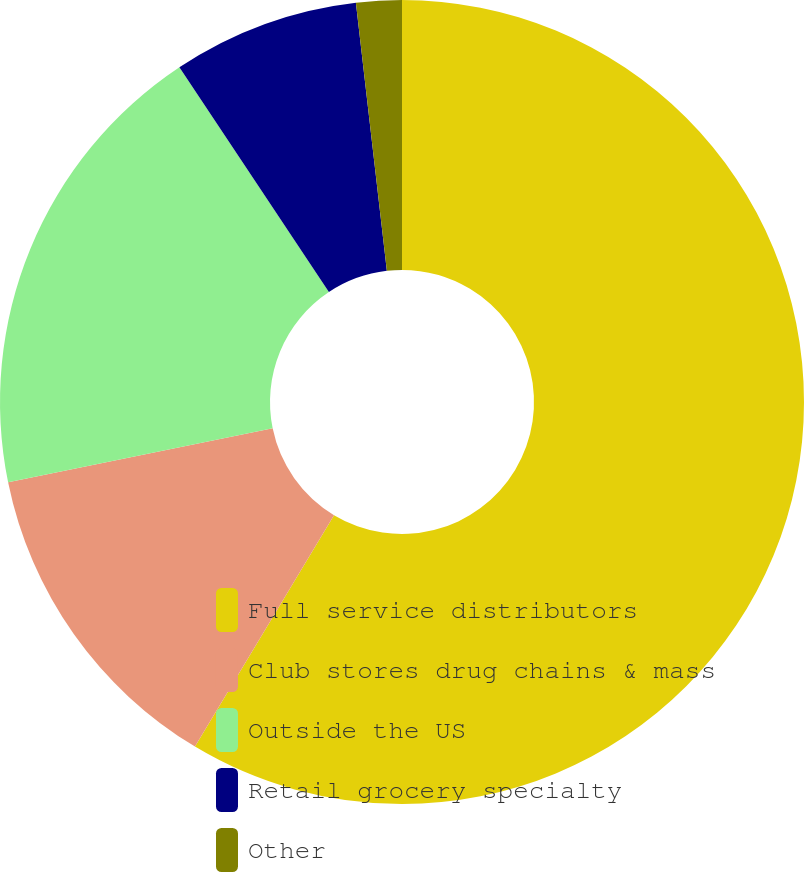Convert chart. <chart><loc_0><loc_0><loc_500><loc_500><pie_chart><fcel>Full service distributors<fcel>Club stores drug chains & mass<fcel>Outside the US<fcel>Retail grocery specialty<fcel>Other<nl><fcel>58.61%<fcel>13.19%<fcel>18.86%<fcel>7.51%<fcel>1.83%<nl></chart> 